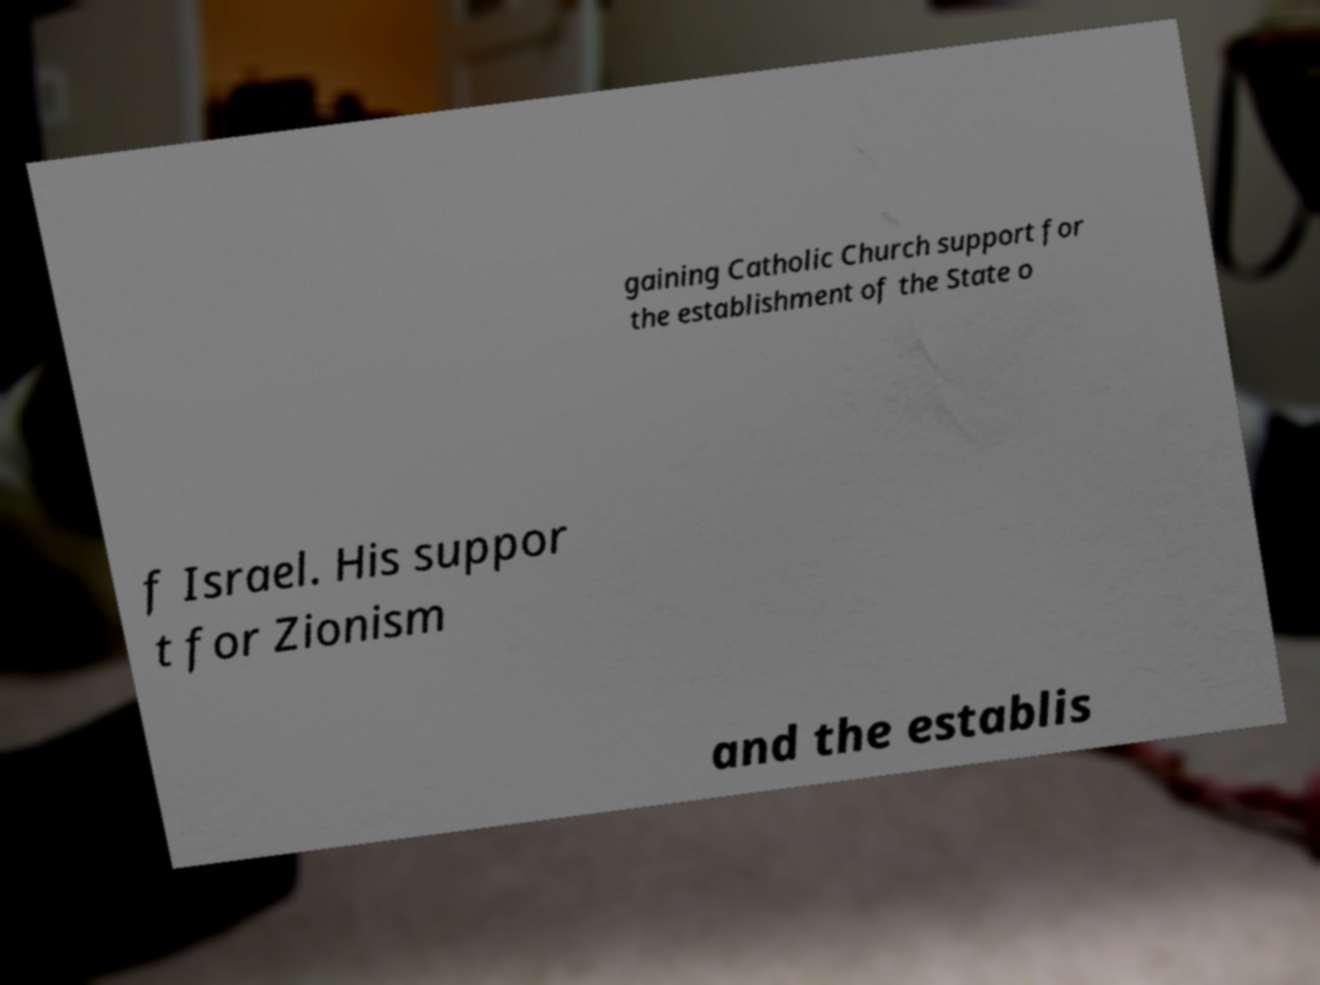Could you assist in decoding the text presented in this image and type it out clearly? gaining Catholic Church support for the establishment of the State o f Israel. His suppor t for Zionism and the establis 